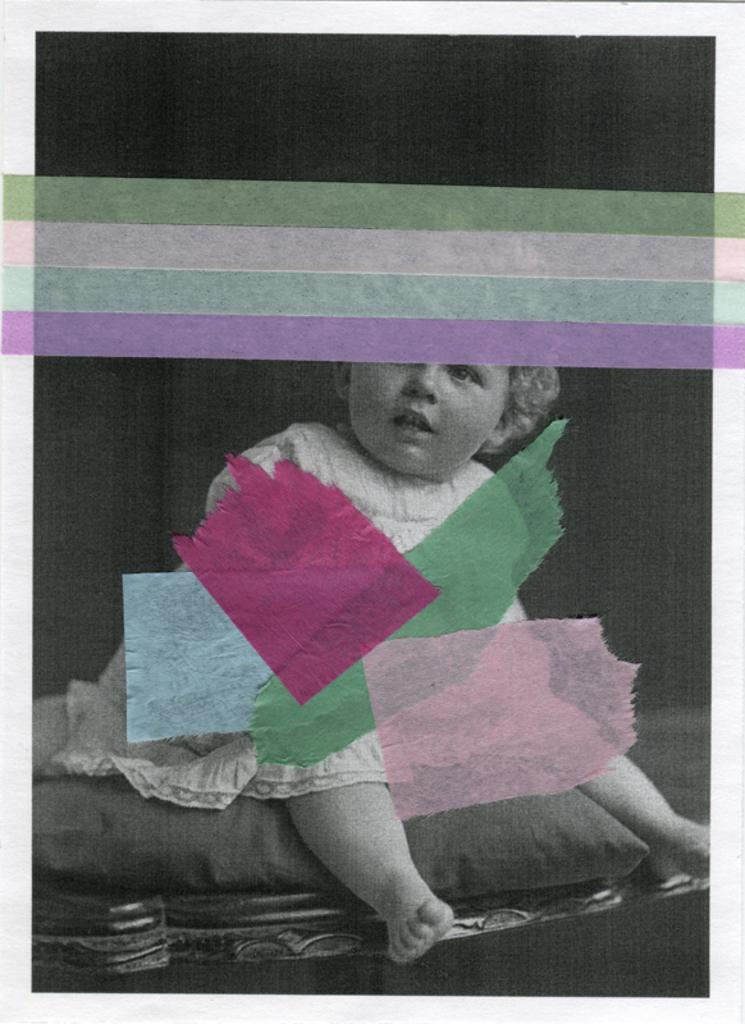What is the color scheme of the image? The image is black and white. Who is present in the image? There is a girl in the image. What is the girl sitting on? The girl is sitting on a pillow. What type of loaf is the girl holding in the image? There is no loaf present in the image; the girl is sitting on a pillow. What punishment is the girl receiving in the image? There is no indication of punishment in the image; the girl is simply sitting on a pillow. 